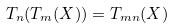<formula> <loc_0><loc_0><loc_500><loc_500>T _ { n } ( T _ { m } ( X ) ) = T _ { m n } ( X )</formula> 